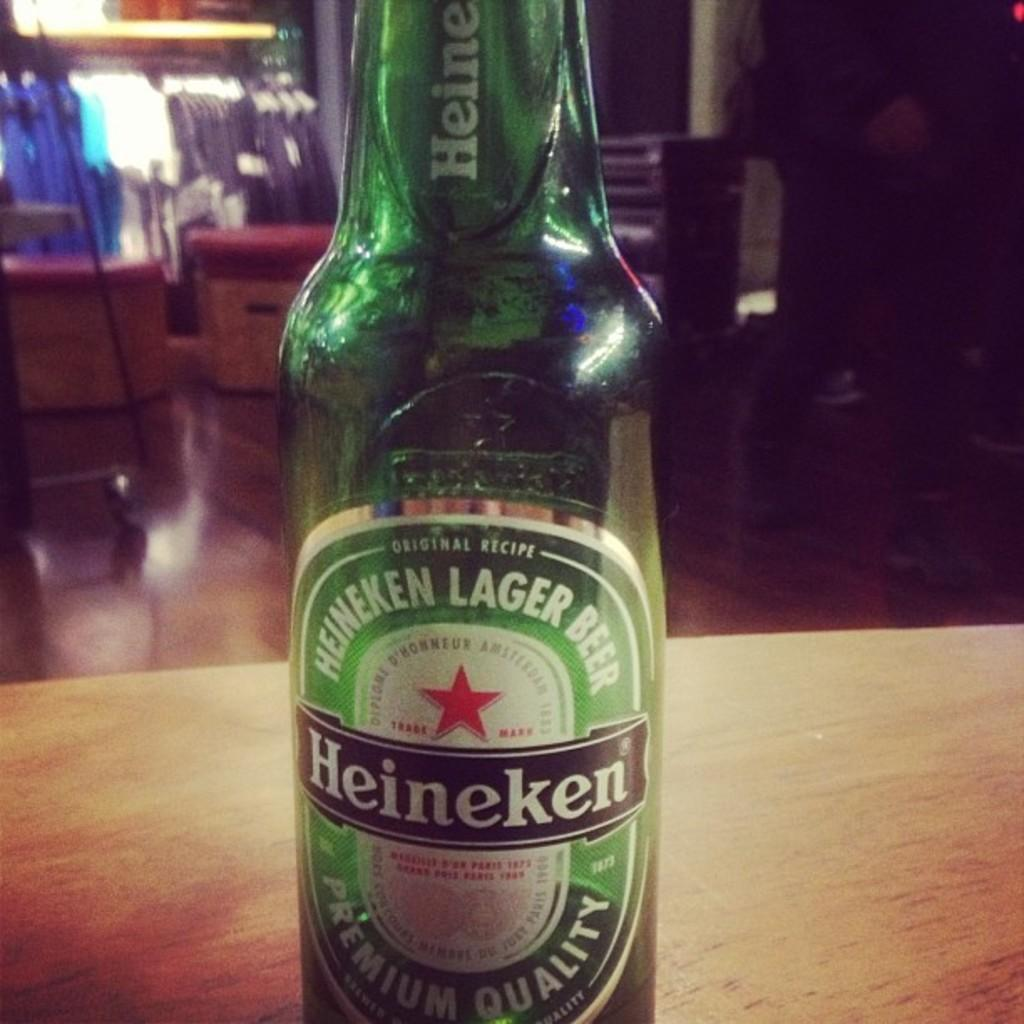<image>
Write a terse but informative summary of the picture. A GREEN BOTTLE OF PREMIUM QUALITY HEINEKEN LAGER BEER 